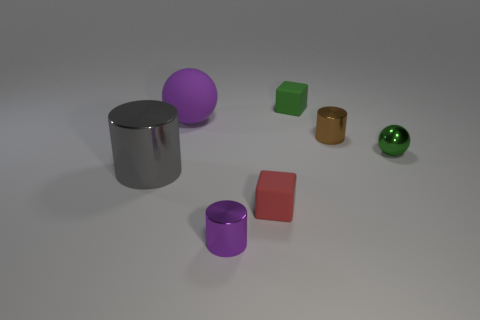Is the number of metallic spheres to the right of the small red object less than the number of tiny green things?
Offer a very short reply. Yes. What number of other objects are the same shape as the gray metal object?
Provide a short and direct response. 2. What number of objects are tiny rubber things that are in front of the green rubber object or metal cylinders to the right of the gray thing?
Provide a short and direct response. 3. What size is the metal object that is on the left side of the brown cylinder and behind the red block?
Offer a terse response. Large. Do the big gray thing that is left of the red rubber object and the small purple metal object have the same shape?
Your answer should be very brief. Yes. What is the size of the rubber cube that is behind the rubber thing that is to the left of the small metallic cylinder left of the brown object?
Provide a succinct answer. Small. There is a cylinder that is the same color as the matte ball; what is its size?
Give a very brief answer. Small. How many objects are big purple spheres or green metal things?
Ensure brevity in your answer.  2. There is a tiny metal thing that is both on the left side of the metallic sphere and in front of the tiny brown cylinder; what is its shape?
Your response must be concise. Cylinder. There is a purple shiny object; is it the same shape as the shiny object to the left of the tiny purple thing?
Keep it short and to the point. Yes. 